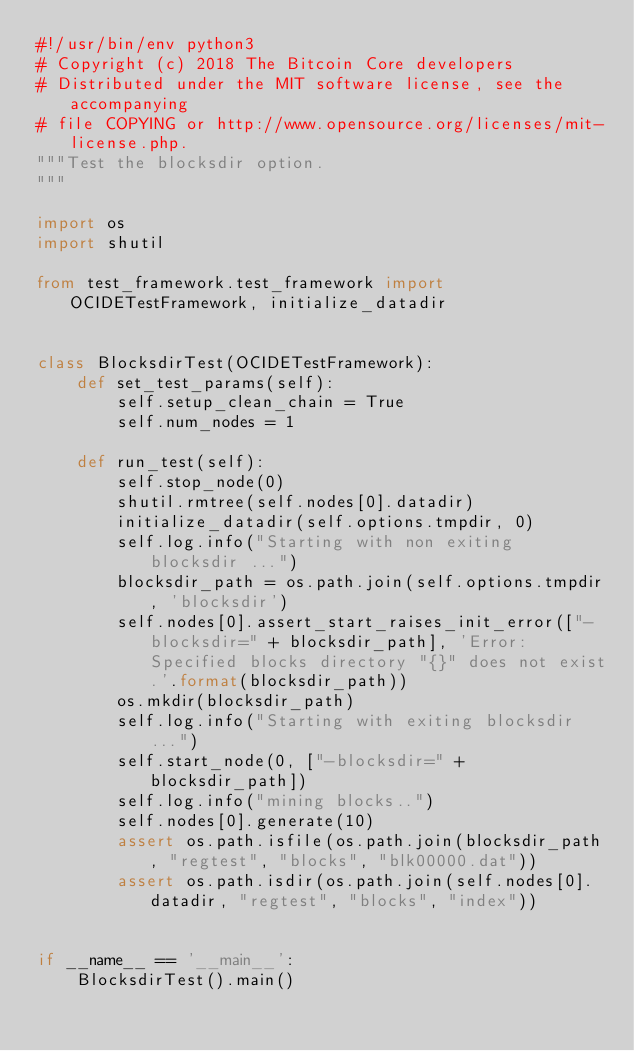<code> <loc_0><loc_0><loc_500><loc_500><_Python_>#!/usr/bin/env python3
# Copyright (c) 2018 The Bitcoin Core developers
# Distributed under the MIT software license, see the accompanying
# file COPYING or http://www.opensource.org/licenses/mit-license.php.
"""Test the blocksdir option.
"""

import os
import shutil

from test_framework.test_framework import OCIDETestFramework, initialize_datadir


class BlocksdirTest(OCIDETestFramework):
    def set_test_params(self):
        self.setup_clean_chain = True
        self.num_nodes = 1

    def run_test(self):
        self.stop_node(0)
        shutil.rmtree(self.nodes[0].datadir)
        initialize_datadir(self.options.tmpdir, 0)
        self.log.info("Starting with non exiting blocksdir ...")
        blocksdir_path = os.path.join(self.options.tmpdir, 'blocksdir')
        self.nodes[0].assert_start_raises_init_error(["-blocksdir=" + blocksdir_path], 'Error: Specified blocks directory "{}" does not exist.'.format(blocksdir_path))
        os.mkdir(blocksdir_path)
        self.log.info("Starting with exiting blocksdir ...")
        self.start_node(0, ["-blocksdir=" + blocksdir_path])
        self.log.info("mining blocks..")
        self.nodes[0].generate(10)
        assert os.path.isfile(os.path.join(blocksdir_path, "regtest", "blocks", "blk00000.dat"))
        assert os.path.isdir(os.path.join(self.nodes[0].datadir, "regtest", "blocks", "index"))


if __name__ == '__main__':
    BlocksdirTest().main()
</code> 